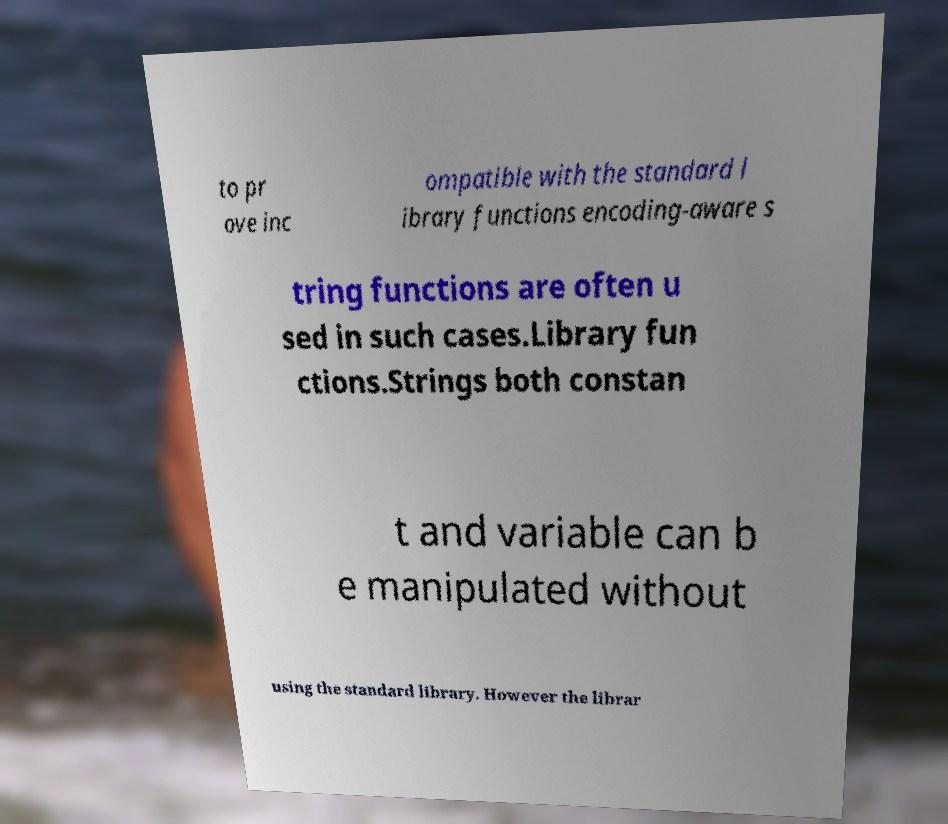Can you read and provide the text displayed in the image?This photo seems to have some interesting text. Can you extract and type it out for me? to pr ove inc ompatible with the standard l ibrary functions encoding-aware s tring functions are often u sed in such cases.Library fun ctions.Strings both constan t and variable can b e manipulated without using the standard library. However the librar 